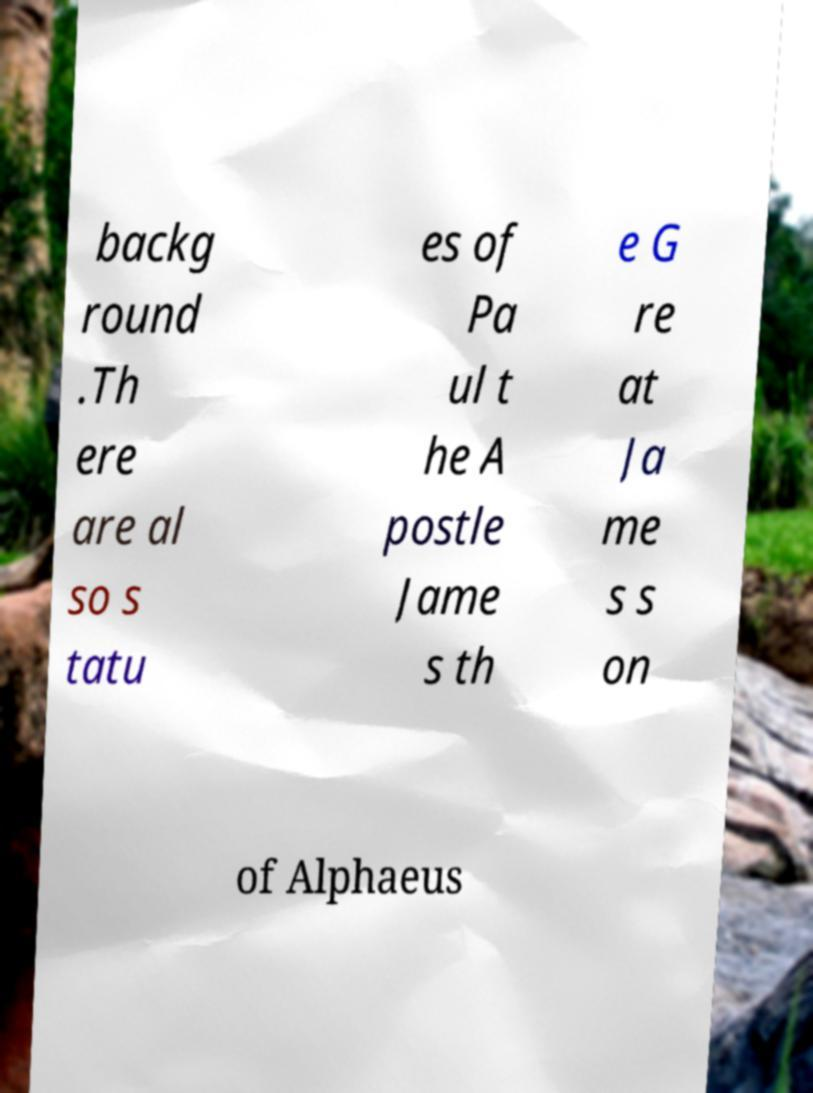Please read and relay the text visible in this image. What does it say? backg round .Th ere are al so s tatu es of Pa ul t he A postle Jame s th e G re at Ja me s s on of Alphaeus 